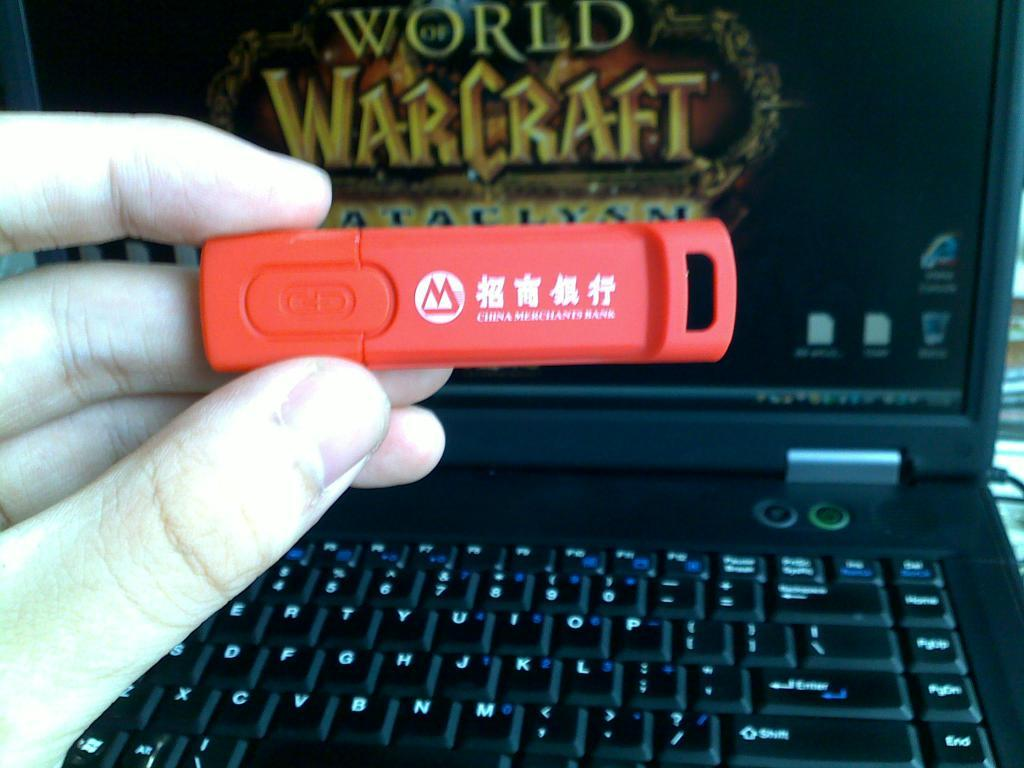Provide a one-sentence caption for the provided image. A red flashdrive in front of a black laptop with world warcraf. 